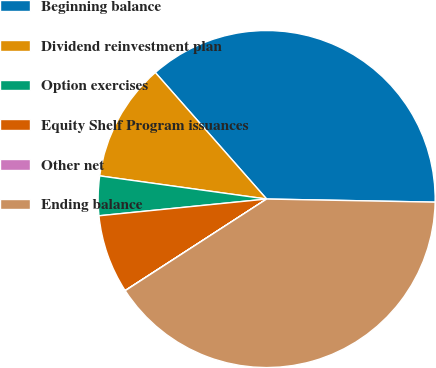Convert chart. <chart><loc_0><loc_0><loc_500><loc_500><pie_chart><fcel>Beginning balance<fcel>Dividend reinvestment plan<fcel>Option exercises<fcel>Equity Shelf Program issuances<fcel>Other net<fcel>Ending balance<nl><fcel>36.78%<fcel>11.32%<fcel>3.78%<fcel>7.55%<fcel>0.02%<fcel>40.55%<nl></chart> 